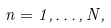Convert formula to latex. <formula><loc_0><loc_0><loc_500><loc_500>n = 1 , \dots , N ,</formula> 